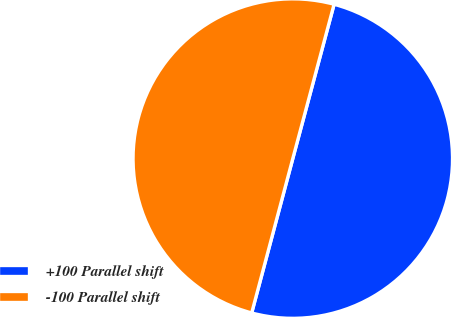Convert chart to OTSL. <chart><loc_0><loc_0><loc_500><loc_500><pie_chart><fcel>+100 Parallel shift<fcel>-100 Parallel shift<nl><fcel>49.98%<fcel>50.02%<nl></chart> 